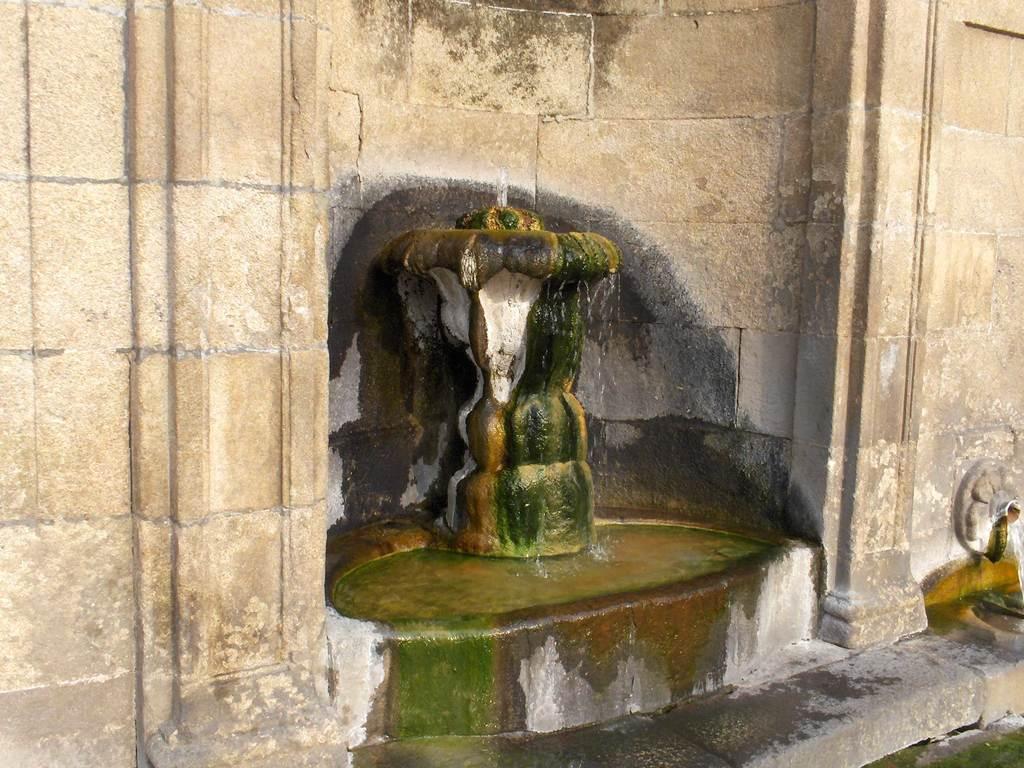Please provide a concise description of this image. In this image, in the middle, we can see a statue. In the background, we can see a wall. 